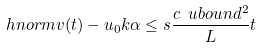Convert formula to latex. <formula><loc_0><loc_0><loc_500><loc_500>\ h n o r m { v ( t ) - u _ { 0 } } { k } { \alpha } \leq s \frac { c \ u b o u n d ^ { 2 } } { L } t</formula> 